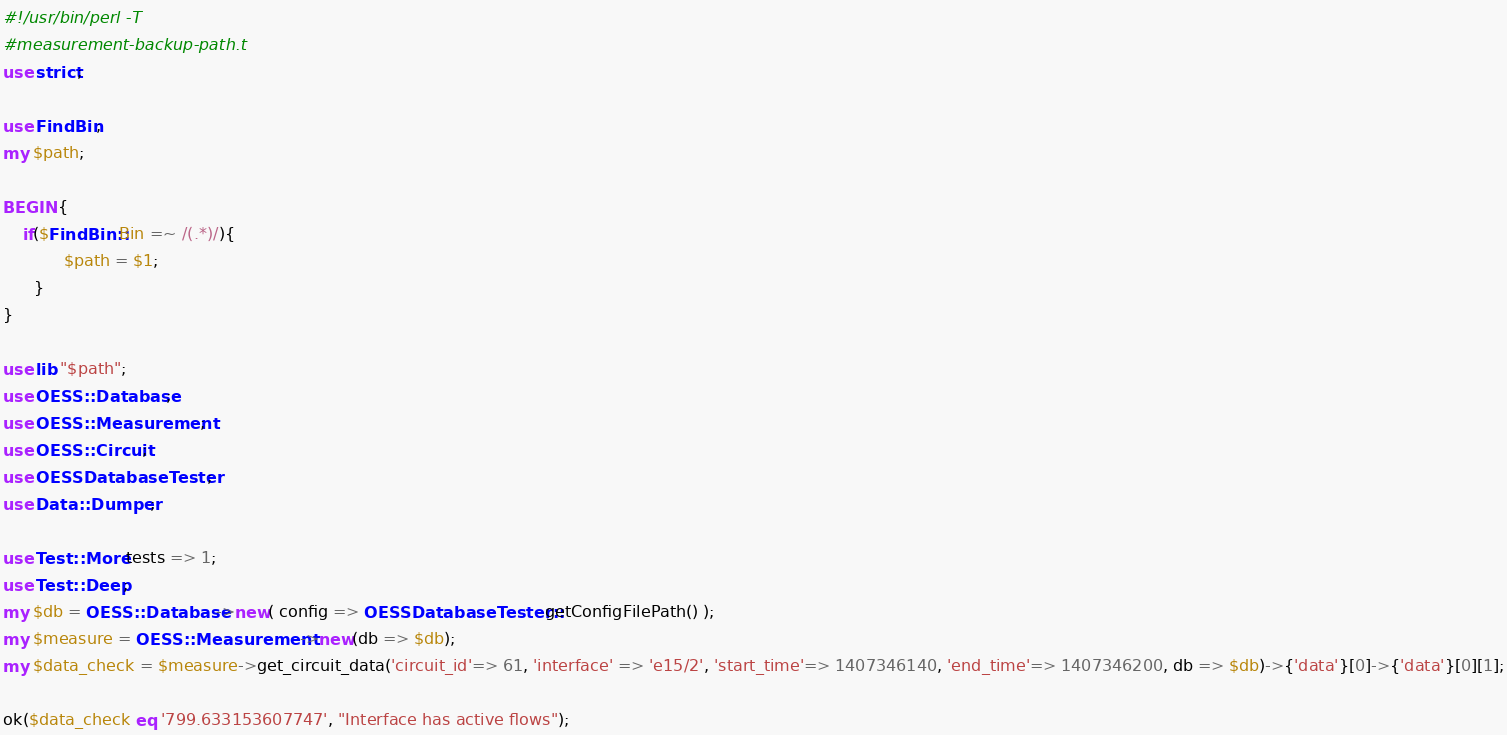<code> <loc_0><loc_0><loc_500><loc_500><_Perl_>#!/usr/bin/perl -T
#measurement-backup-path.t
use strict;

use FindBin;
my $path;

BEGIN {
    if($FindBin::Bin =~ /(.*)/){
            $path = $1;
      }
}

use lib "$path";
use OESS::Database;
use OESS::Measurement;
use OESS::Circuit;
use OESSDatabaseTester;
use Data::Dumper;

use Test::More tests => 1;
use Test::Deep;
my $db = OESS::Database->new( config => OESSDatabaseTester::getConfigFilePath() );
my $measure = OESS::Measurement->new(db => $db);
my $data_check = $measure->get_circuit_data('circuit_id'=> 61, 'interface' => 'e15/2', 'start_time'=> 1407346140, 'end_time'=> 1407346200, db => $db)->{'data'}[0]->{'data'}[0][1];

ok($data_check eq '799.633153607747', "Interface has active flows");
</code> 